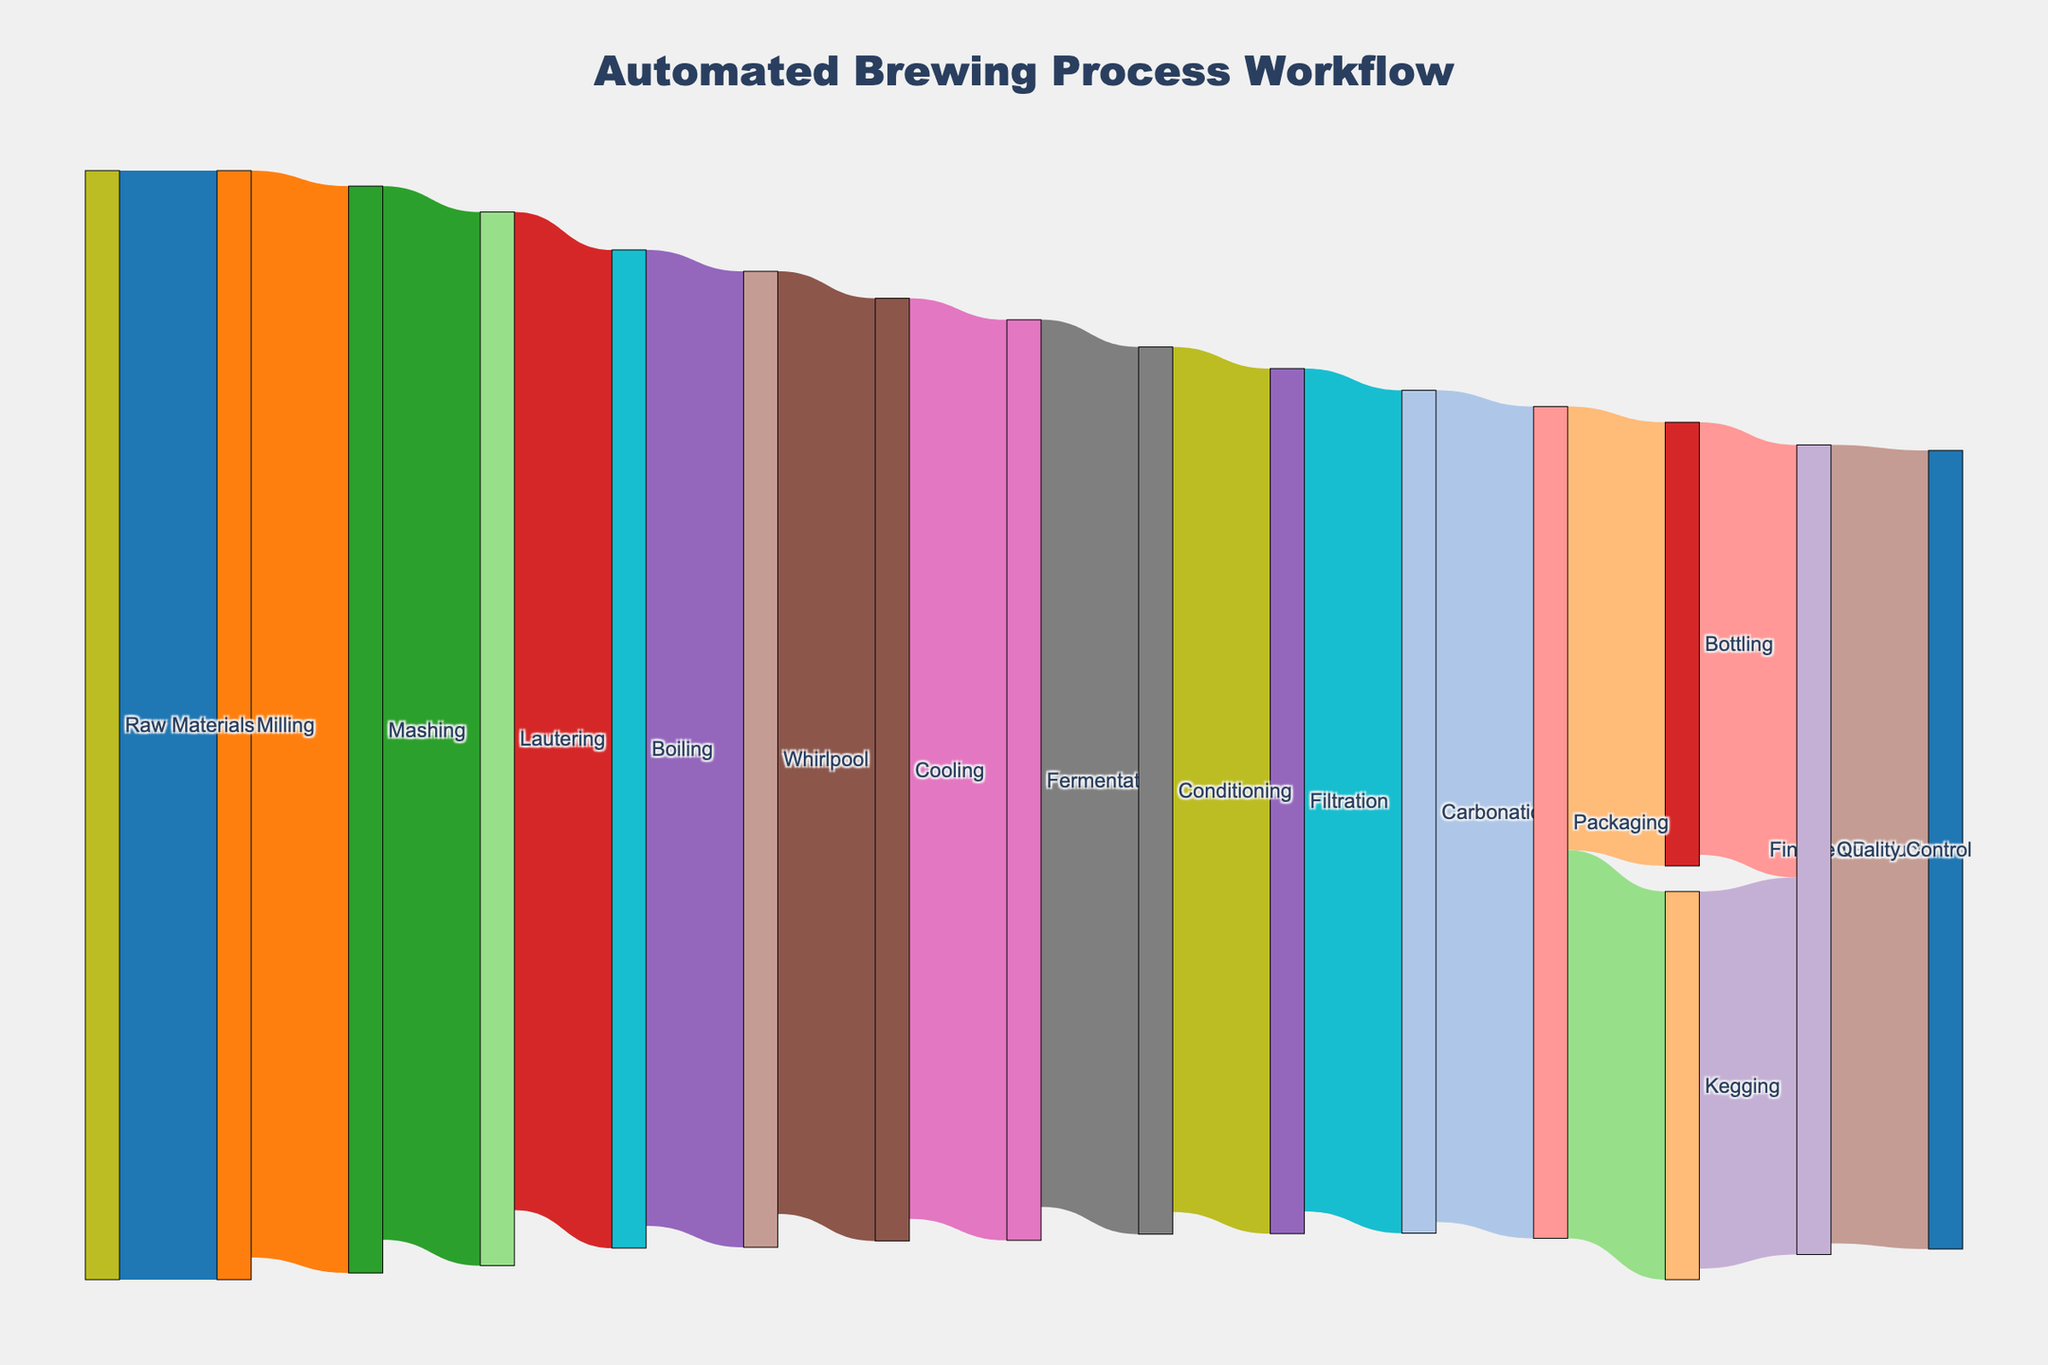What is the title of the Sankey Diagram? The title is displayed at the top of the chart and central to the plot. It summarizes the main focus of the diagram.
Answer: Automated Brewing Process Workflow What is the total amount of raw materials used initially? The initial amount of raw materials is given in the first link originating from 'Raw Materials'. Referring to this link value will provide the answer.
Answer: 100 What are the final stages the product goes through before becoming a finished product? Follow the flow of nodes until you reach the nodes that lead directly to the 'Finished Product' node, which are 'Quality Control'. Thus the stages before this are the final stages.
Answer: Bottling, Kegging, Quality Control What is the difference in value between the amount of raw materials and the packaged product? The raw materials start at 100, and the final values at 'Packaging' are 40 (Bottling) + 35 (Kegging). So the difference is calculated as (100 - (40 + 35)).
Answer: 25 Which stage has the highest reduction in value from the previous stage? Compare the differences between successive stages by subtraction. The stage with the highest subtraction difference indicates the highest reduction.
Answer: Lautering to Boiling (5 units) Are there any stages where the value remains unchanged? Observe the values transitioning from one stage to another. If you find consecutive values without change, those are stages with unchanged values. All stages have a reduction in value.
Answer: No What proportion of the Conditioning value moves to Filtration? Identify the value transitioning from Conditioning to Filtration and divide by the value at Conditioning. Multiply by 100 to express in percentage form.
Answer: (78/80) * 100 = 97.5% How many stages does the cooling process go through until it reaches the finished product? Starting from 'Cooling', count the number of transitions it passes until reaching 'Finished Product'.
Answer: 6 stages Which final product type has a higher value before quality control, bottling, or kegging? Compare the values at the Packaging node for Bottling and Kegging.
Answer: Bottling (40) From the whisk of values, which state has the lowest value contributing to the total process flow? Refer to the values in the link and find the smallest value in the stages.
Answer: Kegging (35) 